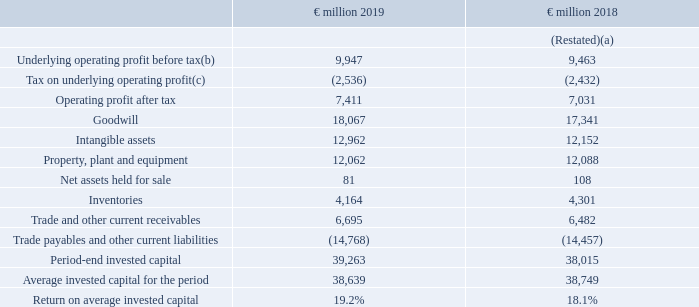Return on invested capital
Return on invested capital (ROIC) is a measure of the return generated on capital invested by the Group. The measure provides a guide rail for longterm value creation and encourages compounding reinvestment within the business and discipline around acquisitions with low returns and long payback. ROIC is calculated as underlying operating profit after tax divided by the annual average of: goodwill, intangible assets, property, plant and equipment, net assets held for sale, inventories, trade and other current receivables, and trade payables and other current liabilities.
(a) Restated following adoption of IFRS 16. See note 1 and note 24 for further details.
(b) See reconciliation of operating profit to underlying operating profit on page 30.
(c) Tax on underlying operating profit is calculated as underlying operating profit before tax multiplied by underlying effective tax rate of 25.5% (2018: 25.7%) which is shown on page 30.
How is the underlying operating profit calculated? Underlying operating profit before tax multiplied by underlying effective tax rate. What is Return on Invested Capital (ROIC) ? Measure of the return generated on capital invested by the group. How is ROIC calculated? Underlying operating profit after tax divided by the annual average of: goodwill, intangible assets, property, plant and equipment, net assets held for sale, inventories, trade and other current receivables, and trade payables and other current liabilities. What is the average Goodwill?
Answer scale should be: million. (18,067 + 17,341) / 2
Answer: 17704. What is the increase / (decrease) in inventories?
Answer scale should be: million. 4,164 - 4,301
Answer: -137. What is the percentage of tax on underlying operating profit before tax in 2019?
Answer scale should be: percent. 2,536 / 9,947
Answer: 25.5. What does Return on Invested Capital (ROIC) represent?  Provides a guide rail for longterm value creation and encourages compounding reinvestment within the business and discipline around acquisitions with low returns and long payback. 